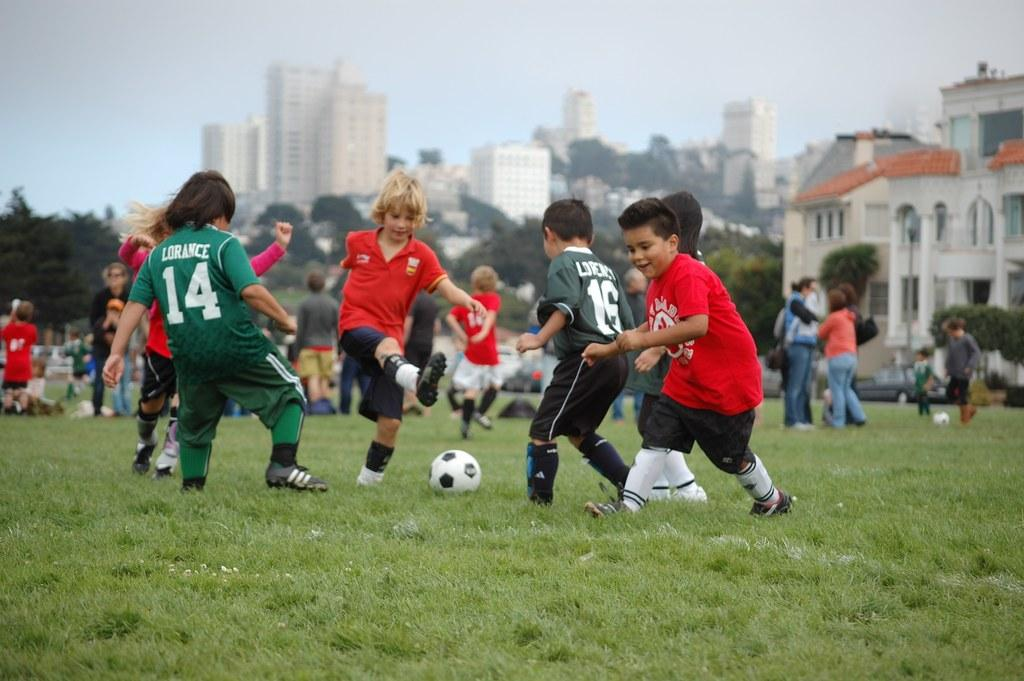<image>
Create a compact narrative representing the image presented. Some young soccer players on a field, number 14 moving towards the ball. 